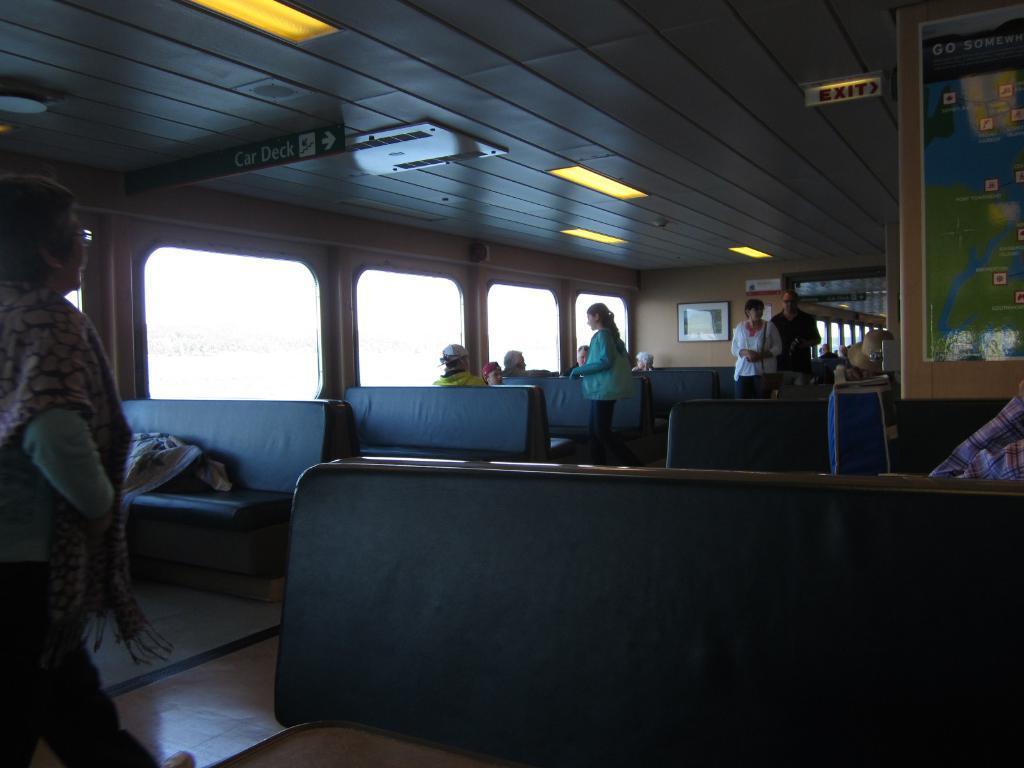Could you give a brief overview of what you see in this image? This image is taken inside the vehicle where we can see there are so many seats one after the other in the line. At the top there are lights and an exit board. There are few people sitting in the seats. On the left side there is a woman who is walking on the floor. On the right side top there is a board on which there is a map. There is a bag on the table, on the right side. In the background there is another compartment. 